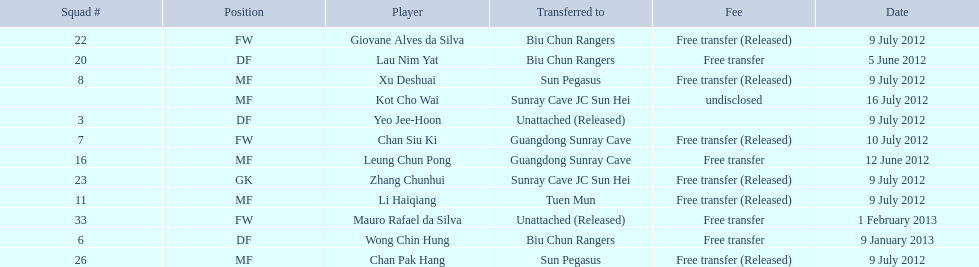Which players are listed? Lau Nim Yat, Leung Chun Pong, Yeo Jee-Hoon, Xu Deshuai, Li Haiqiang, Giovane Alves da Silva, Zhang Chunhui, Chan Pak Hang, Chan Siu Ki, Kot Cho Wai, Wong Chin Hung, Mauro Rafael da Silva. Which dates were players transferred to the biu chun rangers? 5 June 2012, 9 July 2012, 9 January 2013. Of those which is the date for wong chin hung? 9 January 2013. 